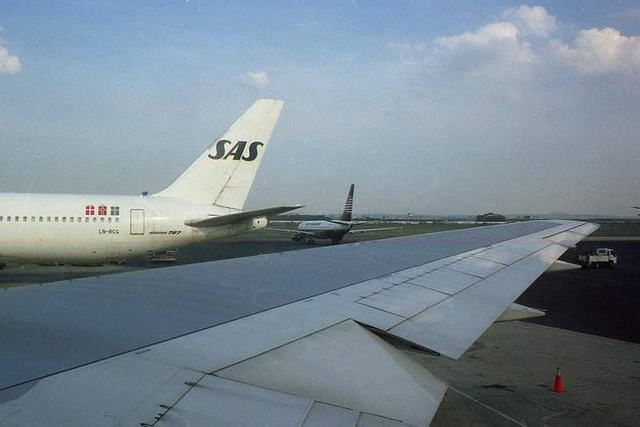Identify the text contained in this image. SAS 